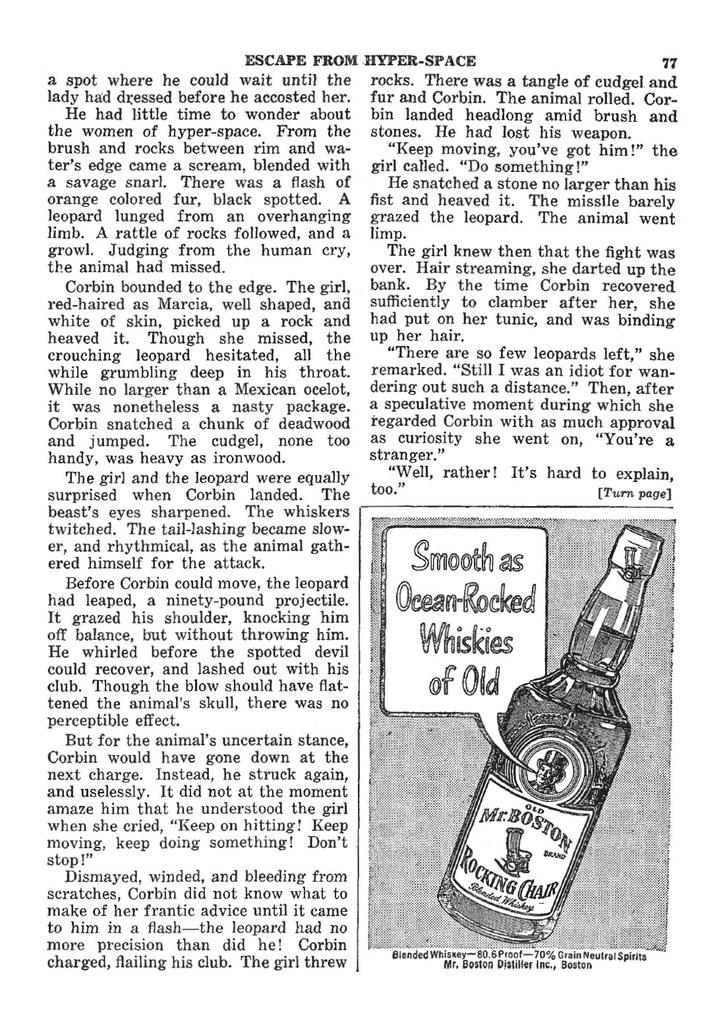<image>
Render a clear and concise summary of the photo. a print of a page with a bottle of Mr Boston whiskey pictured. 